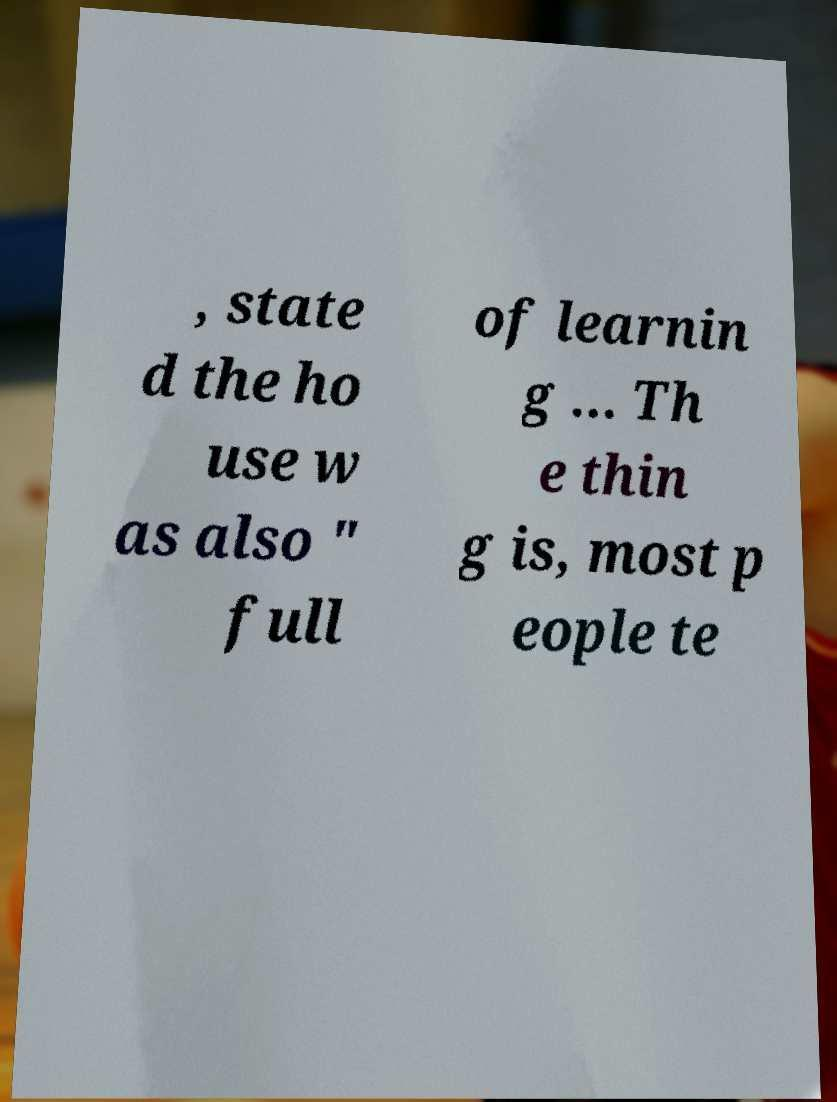Can you read and provide the text displayed in the image?This photo seems to have some interesting text. Can you extract and type it out for me? , state d the ho use w as also " full of learnin g ... Th e thin g is, most p eople te 